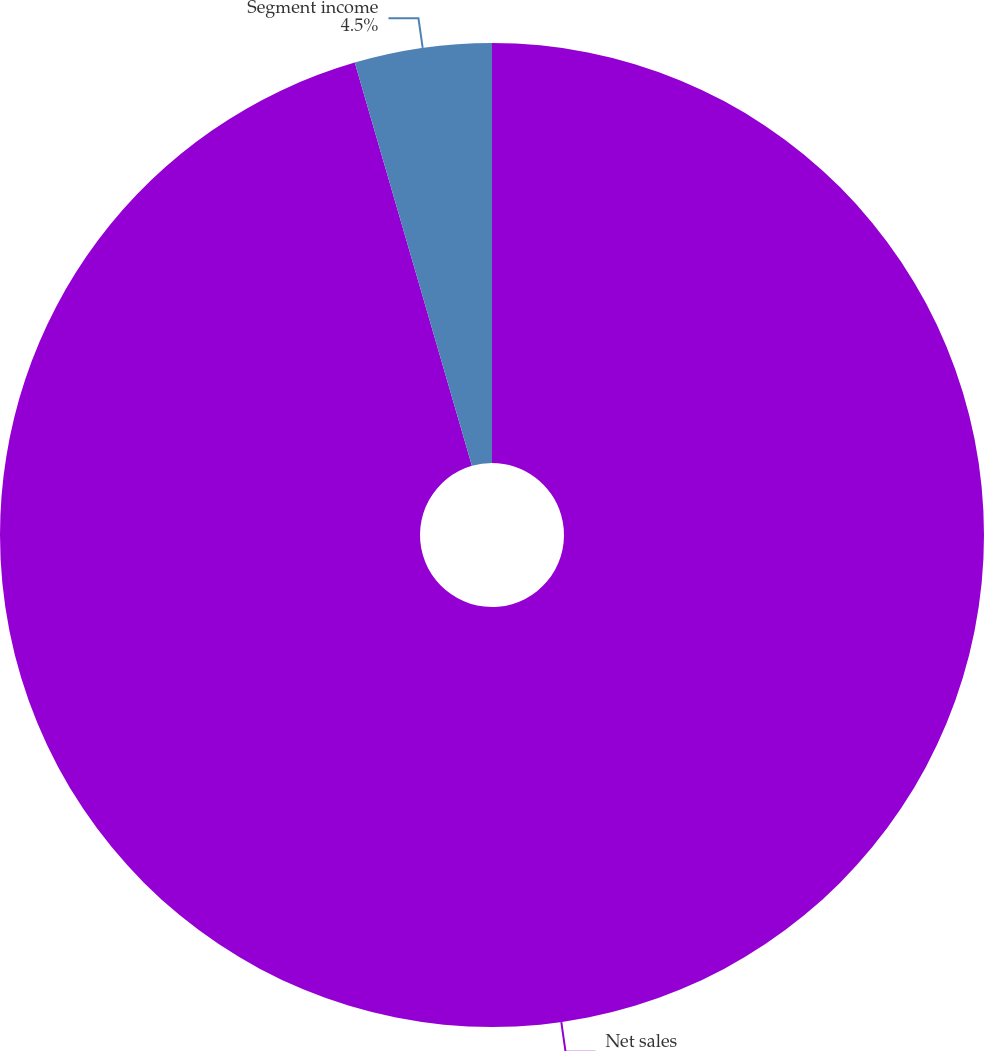Convert chart to OTSL. <chart><loc_0><loc_0><loc_500><loc_500><pie_chart><fcel>Net sales<fcel>Segment income<nl><fcel>95.5%<fcel>4.5%<nl></chart> 